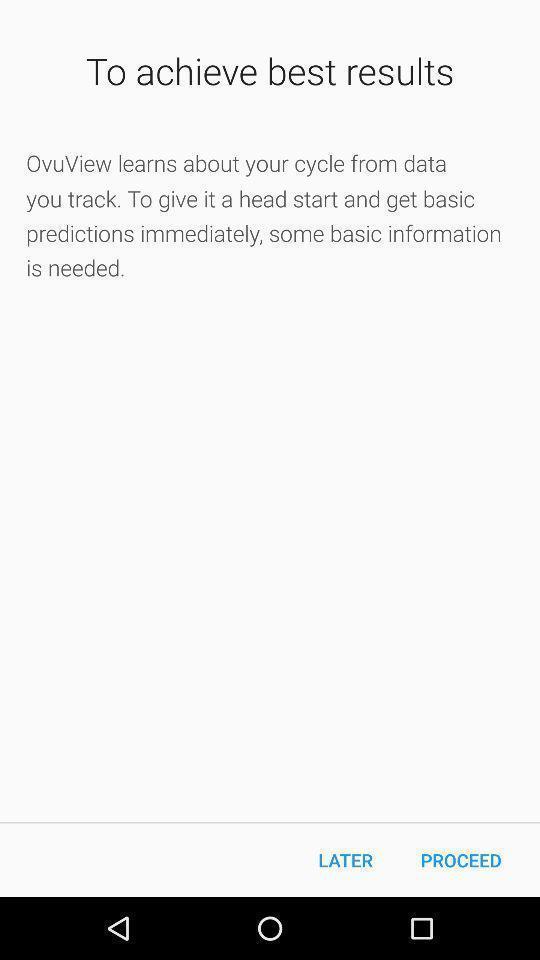Describe the visual elements of this screenshot. Page of a period tracker application. 